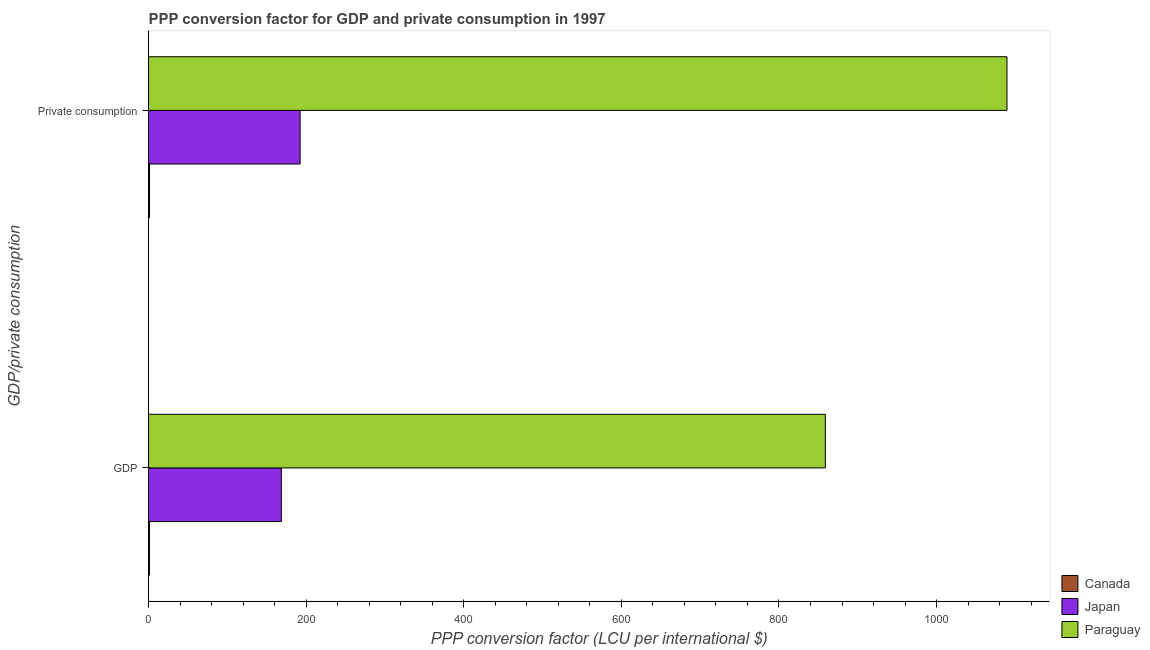Are the number of bars per tick equal to the number of legend labels?
Keep it short and to the point. Yes. Are the number of bars on each tick of the Y-axis equal?
Offer a very short reply. Yes. What is the label of the 2nd group of bars from the top?
Your response must be concise. GDP. What is the ppp conversion factor for gdp in Paraguay?
Keep it short and to the point. 858.84. Across all countries, what is the maximum ppp conversion factor for gdp?
Your answer should be very brief. 858.84. Across all countries, what is the minimum ppp conversion factor for gdp?
Provide a short and direct response. 1.2. In which country was the ppp conversion factor for gdp maximum?
Provide a short and direct response. Paraguay. In which country was the ppp conversion factor for gdp minimum?
Make the answer very short. Canada. What is the total ppp conversion factor for private consumption in the graph?
Ensure brevity in your answer.  1282.92. What is the difference between the ppp conversion factor for gdp in Japan and that in Canada?
Offer a very short reply. 167.34. What is the difference between the ppp conversion factor for private consumption in Paraguay and the ppp conversion factor for gdp in Japan?
Offer a very short reply. 920.77. What is the average ppp conversion factor for private consumption per country?
Ensure brevity in your answer.  427.64. What is the difference between the ppp conversion factor for private consumption and ppp conversion factor for gdp in Japan?
Offer a very short reply. 23.81. What is the ratio of the ppp conversion factor for private consumption in Canada to that in Japan?
Your answer should be compact. 0.01. How many bars are there?
Your answer should be very brief. 6. Are all the bars in the graph horizontal?
Your answer should be very brief. Yes. How many countries are there in the graph?
Provide a short and direct response. 3. Are the values on the major ticks of X-axis written in scientific E-notation?
Offer a terse response. No. Where does the legend appear in the graph?
Offer a very short reply. Bottom right. How are the legend labels stacked?
Give a very brief answer. Vertical. What is the title of the graph?
Your answer should be compact. PPP conversion factor for GDP and private consumption in 1997. Does "Angola" appear as one of the legend labels in the graph?
Your answer should be compact. No. What is the label or title of the X-axis?
Your answer should be compact. PPP conversion factor (LCU per international $). What is the label or title of the Y-axis?
Give a very brief answer. GDP/private consumption. What is the PPP conversion factor (LCU per international $) in Canada in GDP?
Your response must be concise. 1.2. What is the PPP conversion factor (LCU per international $) in Japan in GDP?
Provide a succinct answer. 168.54. What is the PPP conversion factor (LCU per international $) of Paraguay in GDP?
Your answer should be compact. 858.84. What is the PPP conversion factor (LCU per international $) in Canada in  Private consumption?
Provide a succinct answer. 1.26. What is the PPP conversion factor (LCU per international $) of Japan in  Private consumption?
Give a very brief answer. 192.35. What is the PPP conversion factor (LCU per international $) of Paraguay in  Private consumption?
Give a very brief answer. 1089.31. Across all GDP/private consumption, what is the maximum PPP conversion factor (LCU per international $) of Canada?
Ensure brevity in your answer.  1.26. Across all GDP/private consumption, what is the maximum PPP conversion factor (LCU per international $) of Japan?
Provide a short and direct response. 192.35. Across all GDP/private consumption, what is the maximum PPP conversion factor (LCU per international $) in Paraguay?
Provide a succinct answer. 1089.31. Across all GDP/private consumption, what is the minimum PPP conversion factor (LCU per international $) of Canada?
Your answer should be very brief. 1.2. Across all GDP/private consumption, what is the minimum PPP conversion factor (LCU per international $) in Japan?
Provide a succinct answer. 168.54. Across all GDP/private consumption, what is the minimum PPP conversion factor (LCU per international $) in Paraguay?
Your answer should be very brief. 858.84. What is the total PPP conversion factor (LCU per international $) of Canada in the graph?
Keep it short and to the point. 2.46. What is the total PPP conversion factor (LCU per international $) in Japan in the graph?
Give a very brief answer. 360.89. What is the total PPP conversion factor (LCU per international $) in Paraguay in the graph?
Provide a short and direct response. 1948.15. What is the difference between the PPP conversion factor (LCU per international $) in Canada in GDP and that in  Private consumption?
Your answer should be very brief. -0.05. What is the difference between the PPP conversion factor (LCU per international $) of Japan in GDP and that in  Private consumption?
Provide a short and direct response. -23.81. What is the difference between the PPP conversion factor (LCU per international $) of Paraguay in GDP and that in  Private consumption?
Your response must be concise. -230.47. What is the difference between the PPP conversion factor (LCU per international $) in Canada in GDP and the PPP conversion factor (LCU per international $) in Japan in  Private consumption?
Give a very brief answer. -191.15. What is the difference between the PPP conversion factor (LCU per international $) in Canada in GDP and the PPP conversion factor (LCU per international $) in Paraguay in  Private consumption?
Your answer should be very brief. -1088.11. What is the difference between the PPP conversion factor (LCU per international $) of Japan in GDP and the PPP conversion factor (LCU per international $) of Paraguay in  Private consumption?
Your answer should be compact. -920.77. What is the average PPP conversion factor (LCU per international $) in Canada per GDP/private consumption?
Your answer should be compact. 1.23. What is the average PPP conversion factor (LCU per international $) of Japan per GDP/private consumption?
Provide a short and direct response. 180.44. What is the average PPP conversion factor (LCU per international $) of Paraguay per GDP/private consumption?
Keep it short and to the point. 974.08. What is the difference between the PPP conversion factor (LCU per international $) of Canada and PPP conversion factor (LCU per international $) of Japan in GDP?
Ensure brevity in your answer.  -167.34. What is the difference between the PPP conversion factor (LCU per international $) in Canada and PPP conversion factor (LCU per international $) in Paraguay in GDP?
Provide a succinct answer. -857.64. What is the difference between the PPP conversion factor (LCU per international $) in Japan and PPP conversion factor (LCU per international $) in Paraguay in GDP?
Your answer should be compact. -690.3. What is the difference between the PPP conversion factor (LCU per international $) in Canada and PPP conversion factor (LCU per international $) in Japan in  Private consumption?
Provide a short and direct response. -191.09. What is the difference between the PPP conversion factor (LCU per international $) in Canada and PPP conversion factor (LCU per international $) in Paraguay in  Private consumption?
Give a very brief answer. -1088.06. What is the difference between the PPP conversion factor (LCU per international $) of Japan and PPP conversion factor (LCU per international $) of Paraguay in  Private consumption?
Keep it short and to the point. -896.96. What is the ratio of the PPP conversion factor (LCU per international $) of Canada in GDP to that in  Private consumption?
Provide a short and direct response. 0.96. What is the ratio of the PPP conversion factor (LCU per international $) of Japan in GDP to that in  Private consumption?
Your answer should be very brief. 0.88. What is the ratio of the PPP conversion factor (LCU per international $) of Paraguay in GDP to that in  Private consumption?
Give a very brief answer. 0.79. What is the difference between the highest and the second highest PPP conversion factor (LCU per international $) in Canada?
Provide a short and direct response. 0.05. What is the difference between the highest and the second highest PPP conversion factor (LCU per international $) in Japan?
Provide a succinct answer. 23.81. What is the difference between the highest and the second highest PPP conversion factor (LCU per international $) of Paraguay?
Provide a succinct answer. 230.47. What is the difference between the highest and the lowest PPP conversion factor (LCU per international $) of Canada?
Ensure brevity in your answer.  0.05. What is the difference between the highest and the lowest PPP conversion factor (LCU per international $) of Japan?
Your response must be concise. 23.81. What is the difference between the highest and the lowest PPP conversion factor (LCU per international $) in Paraguay?
Ensure brevity in your answer.  230.47. 